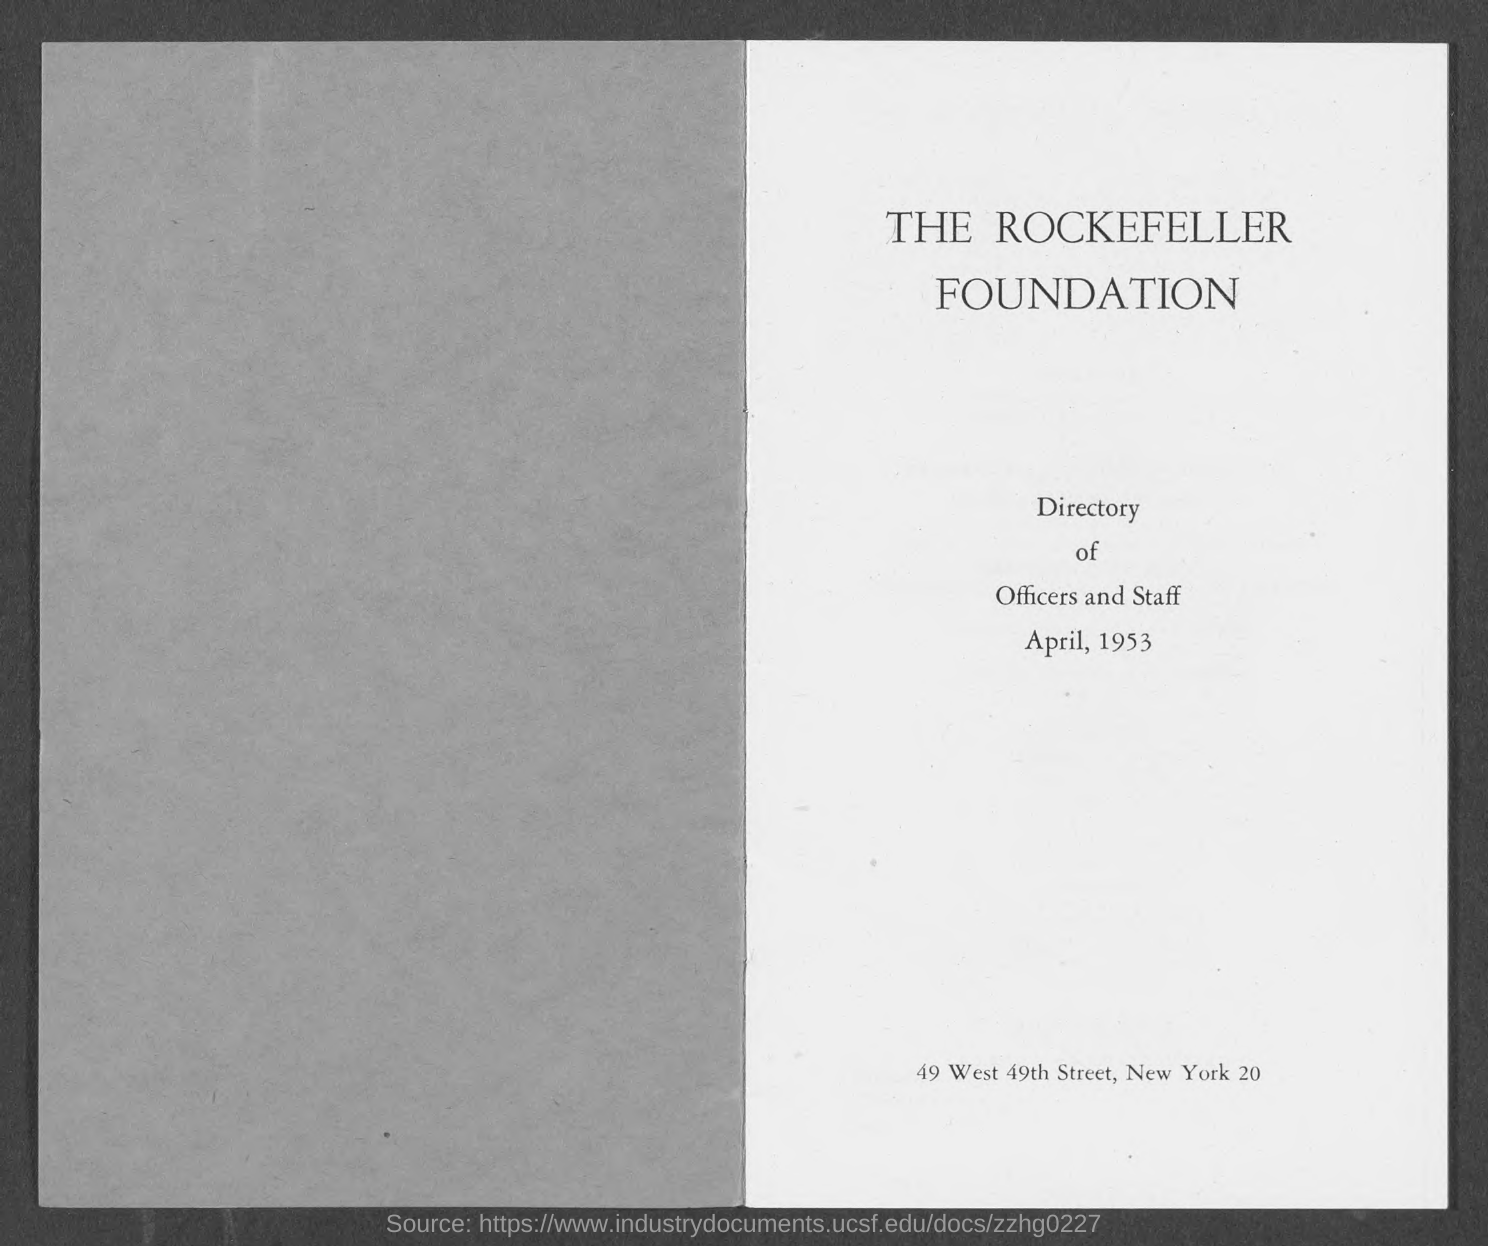List a handful of essential elements in this visual. I hereby declare that the name of the foundation is THE ROCKEFELLER FOUNDATION. 